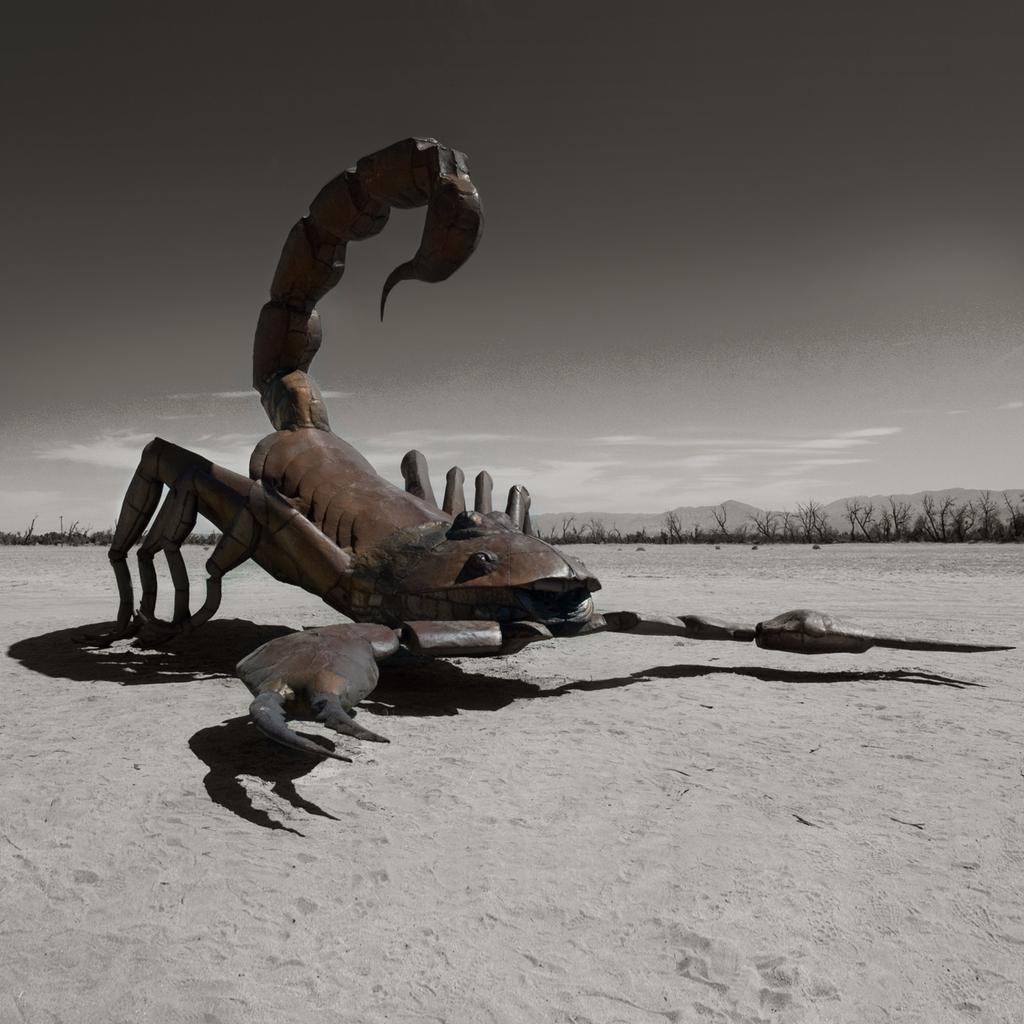What is the main subject of the image? There is a scorpion in the image. Can you describe the appearance of the scorpion? The scorpion is brown and black in color. Where is the scorpion located in the image? The scorpion is on the sand. What can be seen in the background of the image? There are trees, mountains, and the sky visible in the background of the image. How many ants are carrying the watch in the image? There are no ants or watches present in the image. What form does the scorpion take in the image? The scorpion is in its natural form, as it is a living creature. 